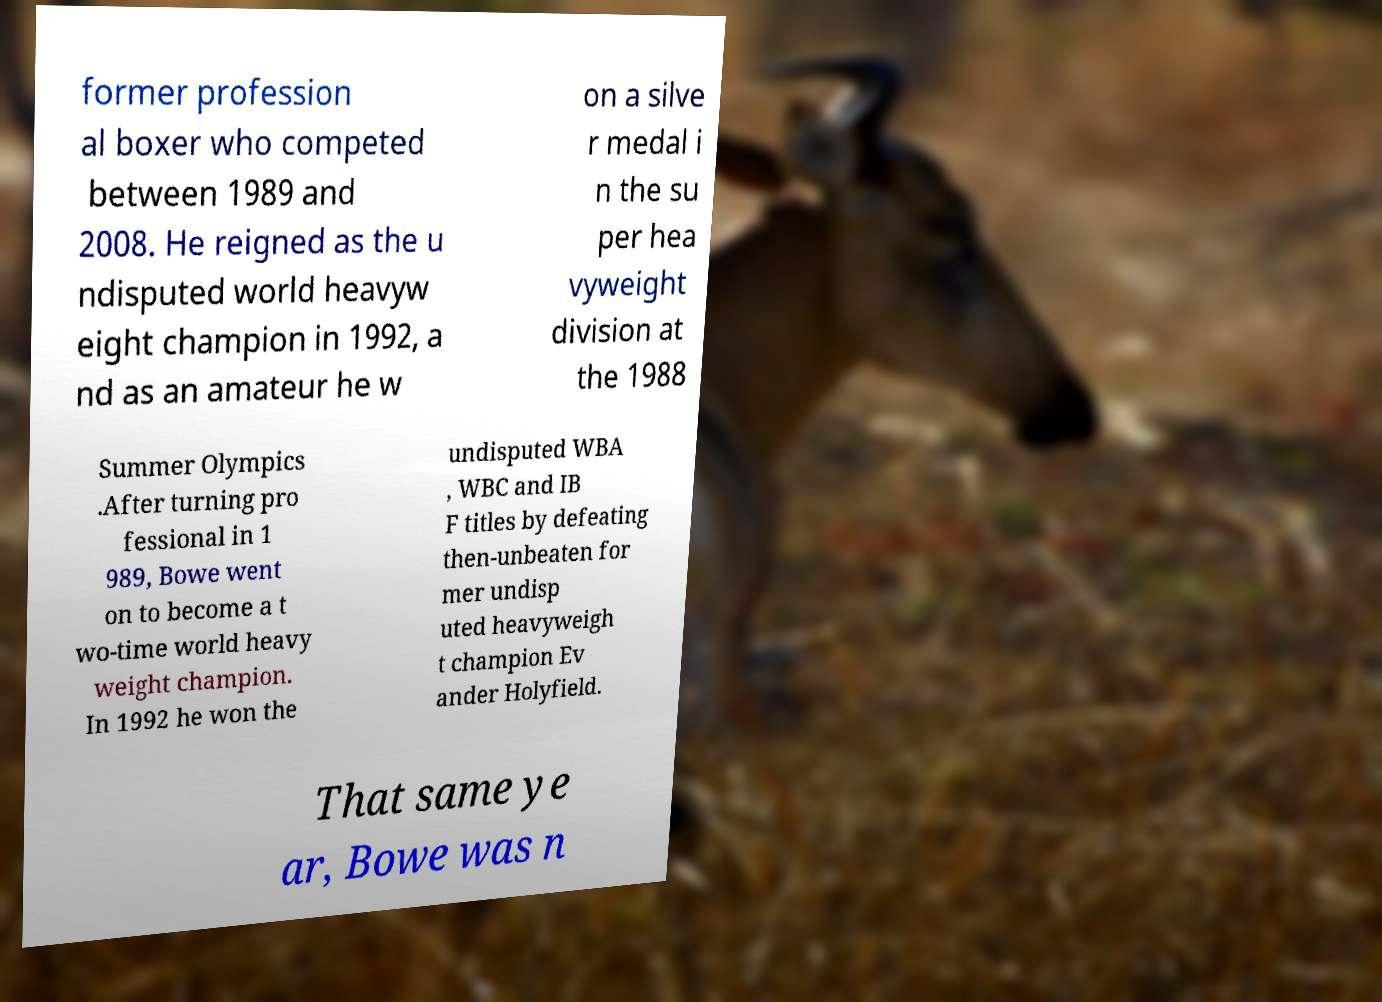For documentation purposes, I need the text within this image transcribed. Could you provide that? former profession al boxer who competed between 1989 and 2008. He reigned as the u ndisputed world heavyw eight champion in 1992, a nd as an amateur he w on a silve r medal i n the su per hea vyweight division at the 1988 Summer Olympics .After turning pro fessional in 1 989, Bowe went on to become a t wo-time world heavy weight champion. In 1992 he won the undisputed WBA , WBC and IB F titles by defeating then-unbeaten for mer undisp uted heavyweigh t champion Ev ander Holyfield. That same ye ar, Bowe was n 